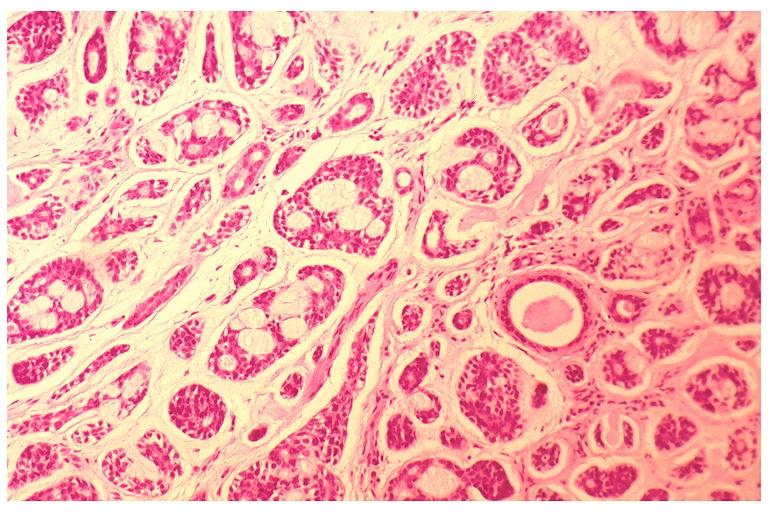what is present?
Answer the question using a single word or phrase. Oral 